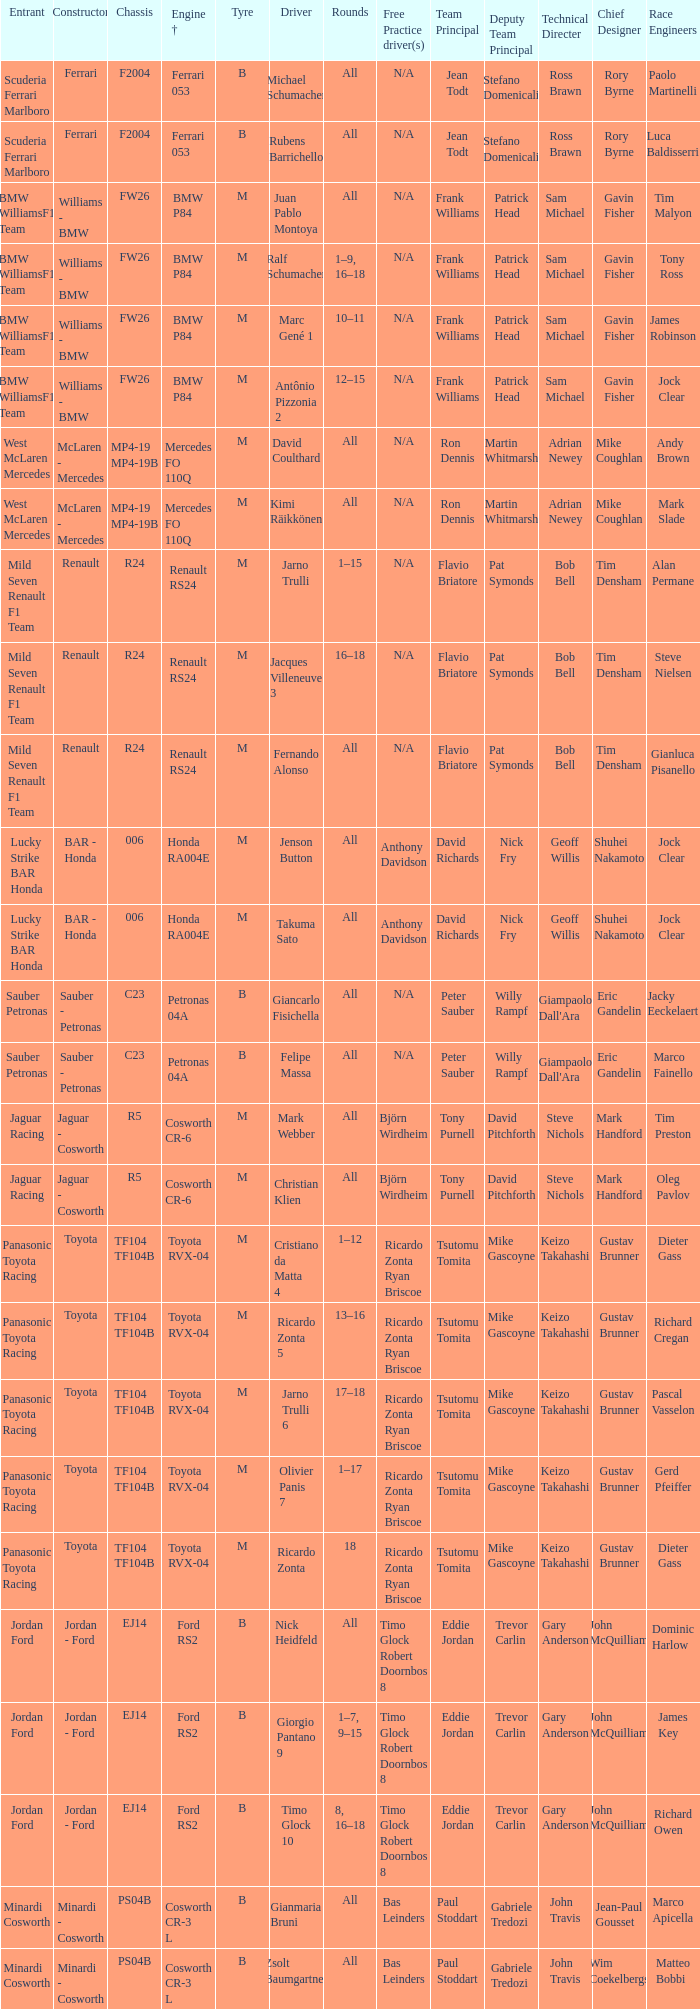What kind of free practice is there with a Ford RS2 engine +? Timo Glock Robert Doornbos 8, Timo Glock Robert Doornbos 8, Timo Glock Robert Doornbos 8. 